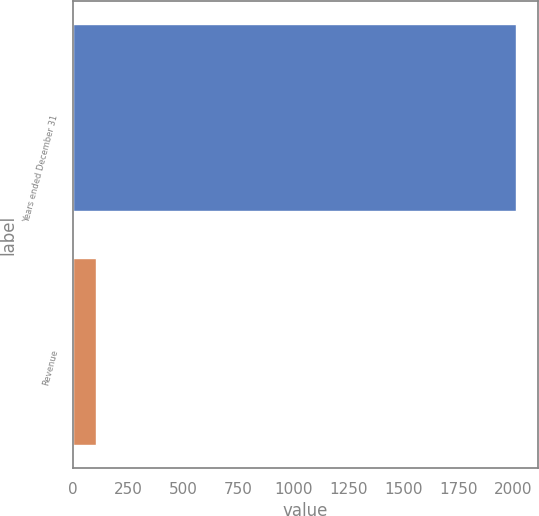Convert chart to OTSL. <chart><loc_0><loc_0><loc_500><loc_500><bar_chart><fcel>Years ended December 31<fcel>Revenue<nl><fcel>2012<fcel>106<nl></chart> 